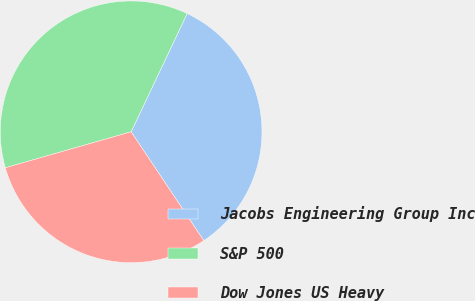<chart> <loc_0><loc_0><loc_500><loc_500><pie_chart><fcel>Jacobs Engineering Group Inc<fcel>S&P 500<fcel>Dow Jones US Heavy<nl><fcel>33.59%<fcel>36.47%<fcel>29.93%<nl></chart> 